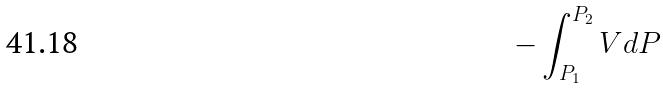Convert formula to latex. <formula><loc_0><loc_0><loc_500><loc_500>- \int _ { P _ { 1 } } ^ { P _ { 2 } } V d P</formula> 